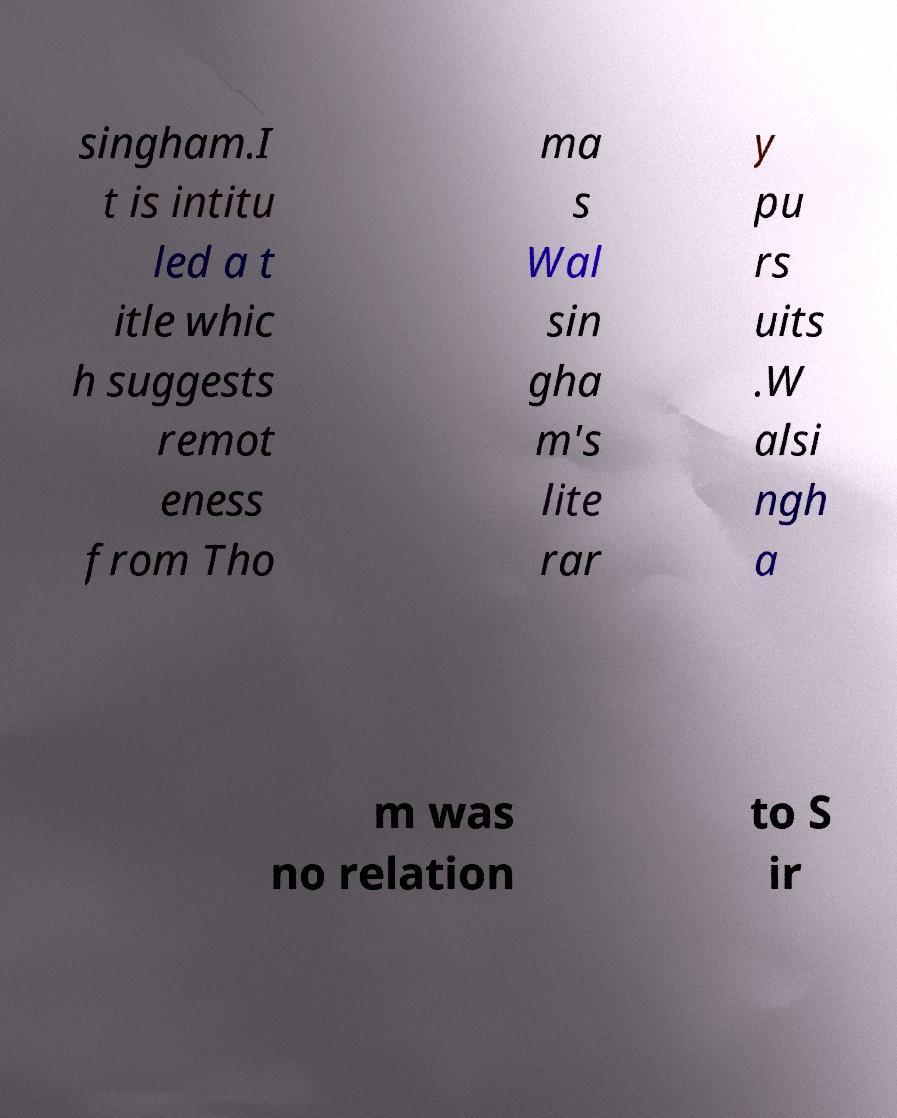What messages or text are displayed in this image? I need them in a readable, typed format. singham.I t is intitu led a t itle whic h suggests remot eness from Tho ma s Wal sin gha m's lite rar y pu rs uits .W alsi ngh a m was no relation to S ir 